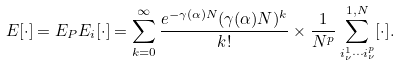<formula> <loc_0><loc_0><loc_500><loc_500>E [ \cdot ] = E _ { P } E _ { i } [ \cdot ] = \sum _ { k = 0 } ^ { \infty } \frac { e ^ { - \gamma ( \alpha ) N } ( \gamma ( \alpha ) N ) ^ { k } } { k ! } \times \frac { 1 } { N ^ { p } } \sum _ { i _ { \nu } ^ { 1 } \cdots i _ { \nu } ^ { p } } ^ { 1 , N } [ \cdot ] .</formula> 